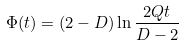Convert formula to latex. <formula><loc_0><loc_0><loc_500><loc_500>\Phi ( t ) = ( 2 - D ) \ln \frac { 2 Q t } { D - 2 }</formula> 